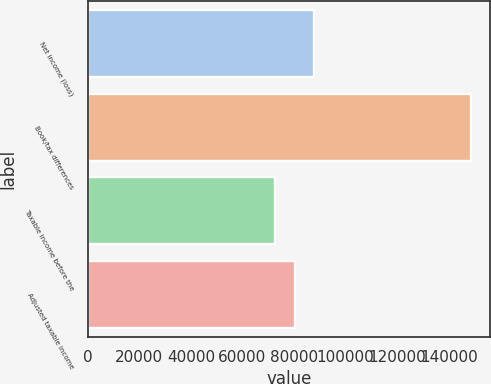Convert chart. <chart><loc_0><loc_0><loc_500><loc_500><bar_chart><fcel>Net income (loss)<fcel>Book/tax differences<fcel>Taxable income before the<fcel>Adjusted taxable income<nl><fcel>87767.6<fcel>148462<fcel>72594<fcel>80180.8<nl></chart> 